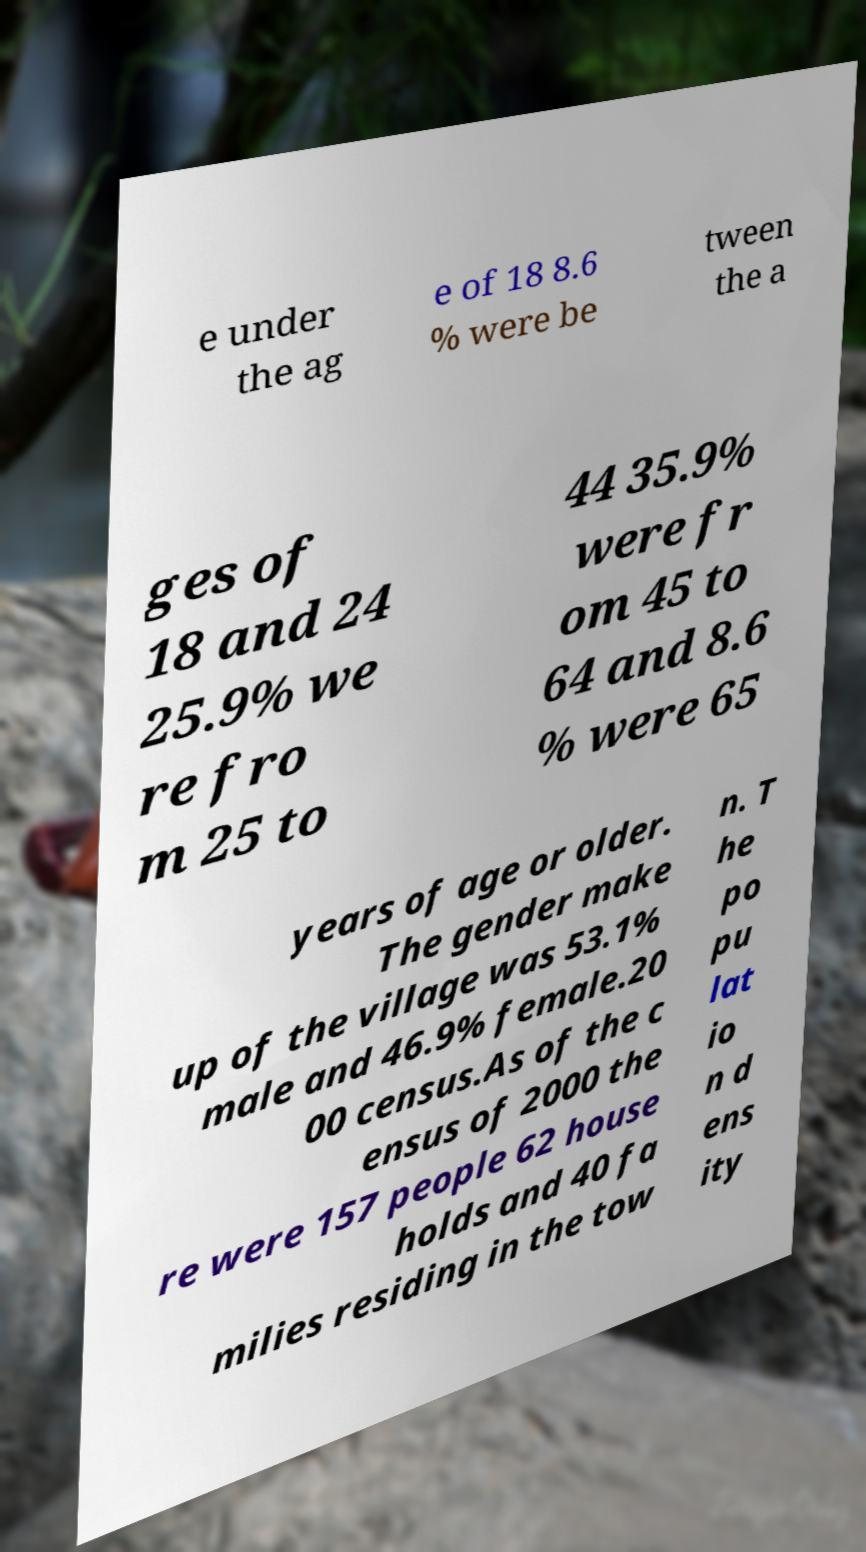For documentation purposes, I need the text within this image transcribed. Could you provide that? e under the ag e of 18 8.6 % were be tween the a ges of 18 and 24 25.9% we re fro m 25 to 44 35.9% were fr om 45 to 64 and 8.6 % were 65 years of age or older. The gender make up of the village was 53.1% male and 46.9% female.20 00 census.As of the c ensus of 2000 the re were 157 people 62 house holds and 40 fa milies residing in the tow n. T he po pu lat io n d ens ity 